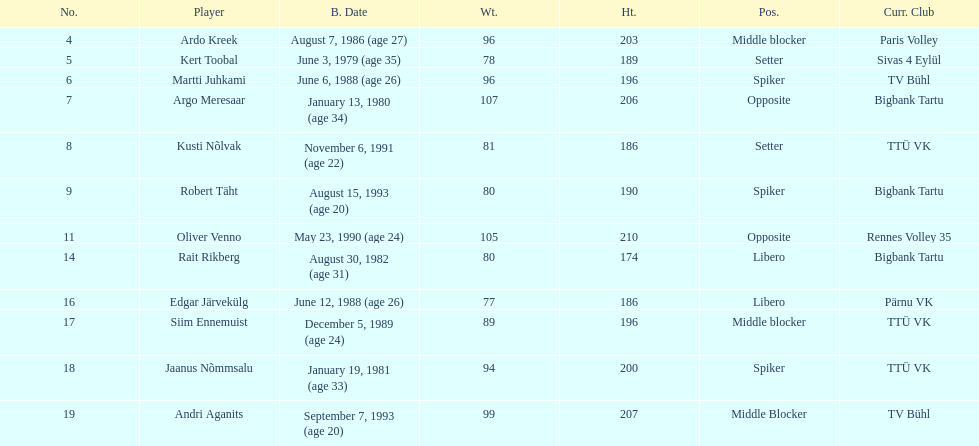Kert toobal is the oldest who is the next oldest player listed? Argo Meresaar. Would you be able to parse every entry in this table? {'header': ['No.', 'Player', 'B. Date', 'Wt.', 'Ht.', 'Pos.', 'Curr. Club'], 'rows': [['4', 'Ardo Kreek', 'August 7, 1986 (age\xa027)', '96', '203', 'Middle blocker', 'Paris Volley'], ['5', 'Kert Toobal', 'June 3, 1979 (age\xa035)', '78', '189', 'Setter', 'Sivas 4 Eylül'], ['6', 'Martti Juhkami', 'June 6, 1988 (age\xa026)', '96', '196', 'Spiker', 'TV Bühl'], ['7', 'Argo Meresaar', 'January 13, 1980 (age\xa034)', '107', '206', 'Opposite', 'Bigbank Tartu'], ['8', 'Kusti Nõlvak', 'November 6, 1991 (age\xa022)', '81', '186', 'Setter', 'TTÜ VK'], ['9', 'Robert Täht', 'August 15, 1993 (age\xa020)', '80', '190', 'Spiker', 'Bigbank Tartu'], ['11', 'Oliver Venno', 'May 23, 1990 (age\xa024)', '105', '210', 'Opposite', 'Rennes Volley 35'], ['14', 'Rait Rikberg', 'August 30, 1982 (age\xa031)', '80', '174', 'Libero', 'Bigbank Tartu'], ['16', 'Edgar Järvekülg', 'June 12, 1988 (age\xa026)', '77', '186', 'Libero', 'Pärnu VK'], ['17', 'Siim Ennemuist', 'December 5, 1989 (age\xa024)', '89', '196', 'Middle blocker', 'TTÜ VK'], ['18', 'Jaanus Nõmmsalu', 'January 19, 1981 (age\xa033)', '94', '200', 'Spiker', 'TTÜ VK'], ['19', 'Andri Aganits', 'September 7, 1993 (age\xa020)', '99', '207', 'Middle Blocker', 'TV Bühl']]} 